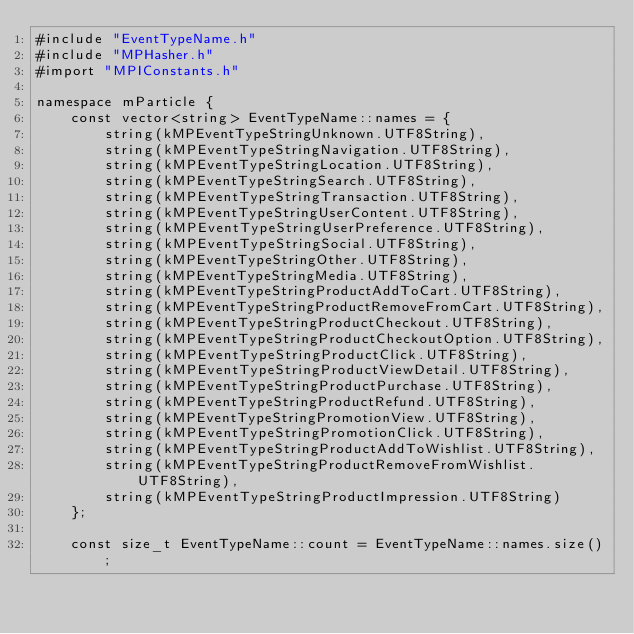Convert code to text. <code><loc_0><loc_0><loc_500><loc_500><_ObjectiveC_>#include "EventTypeName.h"
#include "MPHasher.h"
#import "MPIConstants.h"

namespace mParticle {
    const vector<string> EventTypeName::names = {
        string(kMPEventTypeStringUnknown.UTF8String),
        string(kMPEventTypeStringNavigation.UTF8String),
        string(kMPEventTypeStringLocation.UTF8String),
        string(kMPEventTypeStringSearch.UTF8String),
        string(kMPEventTypeStringTransaction.UTF8String),
        string(kMPEventTypeStringUserContent.UTF8String),
        string(kMPEventTypeStringUserPreference.UTF8String),
        string(kMPEventTypeStringSocial.UTF8String),
        string(kMPEventTypeStringOther.UTF8String),
        string(kMPEventTypeStringMedia.UTF8String),
        string(kMPEventTypeStringProductAddToCart.UTF8String),
        string(kMPEventTypeStringProductRemoveFromCart.UTF8String),
        string(kMPEventTypeStringProductCheckout.UTF8String),
        string(kMPEventTypeStringProductCheckoutOption.UTF8String),
        string(kMPEventTypeStringProductClick.UTF8String),
        string(kMPEventTypeStringProductViewDetail.UTF8String),
        string(kMPEventTypeStringProductPurchase.UTF8String),
        string(kMPEventTypeStringProductRefund.UTF8String),
        string(kMPEventTypeStringPromotionView.UTF8String),
        string(kMPEventTypeStringPromotionClick.UTF8String),
        string(kMPEventTypeStringProductAddToWishlist.UTF8String),
        string(kMPEventTypeStringProductRemoveFromWishlist.UTF8String),
        string(kMPEventTypeStringProductImpression.UTF8String)
    };
    
    const size_t EventTypeName::count = EventTypeName::names.size();
    </code> 